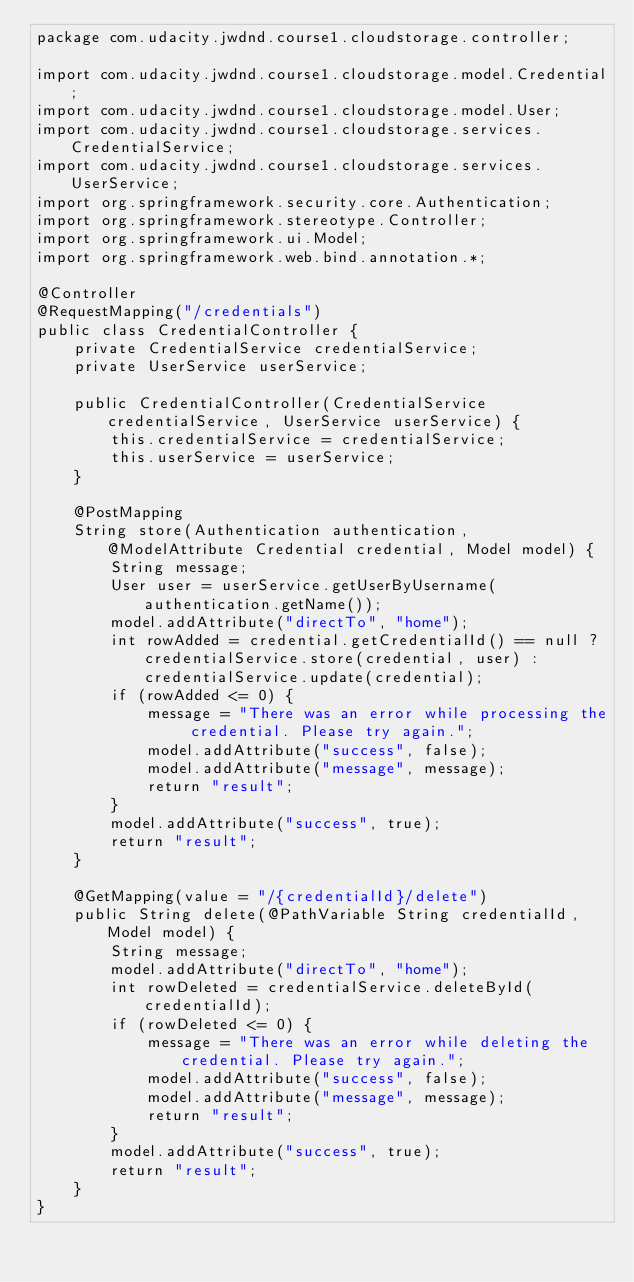<code> <loc_0><loc_0><loc_500><loc_500><_Java_>package com.udacity.jwdnd.course1.cloudstorage.controller;

import com.udacity.jwdnd.course1.cloudstorage.model.Credential;
import com.udacity.jwdnd.course1.cloudstorage.model.User;
import com.udacity.jwdnd.course1.cloudstorage.services.CredentialService;
import com.udacity.jwdnd.course1.cloudstorage.services.UserService;
import org.springframework.security.core.Authentication;
import org.springframework.stereotype.Controller;
import org.springframework.ui.Model;
import org.springframework.web.bind.annotation.*;

@Controller
@RequestMapping("/credentials")
public class CredentialController {
    private CredentialService credentialService;
    private UserService userService;

    public CredentialController(CredentialService credentialService, UserService userService) {
        this.credentialService = credentialService;
        this.userService = userService;
    }

    @PostMapping
    String store(Authentication authentication, @ModelAttribute Credential credential, Model model) {
        String message;
        User user = userService.getUserByUsername(authentication.getName());
        model.addAttribute("directTo", "home");
        int rowAdded = credential.getCredentialId() == null ? credentialService.store(credential, user) : credentialService.update(credential);
        if (rowAdded <= 0) {
            message = "There was an error while processing the credential. Please try again.";
            model.addAttribute("success", false);
            model.addAttribute("message", message);
            return "result";
        }
        model.addAttribute("success", true);
        return "result";
    }

    @GetMapping(value = "/{credentialId}/delete")
    public String delete(@PathVariable String credentialId, Model model) {
        String message;
        model.addAttribute("directTo", "home");
        int rowDeleted = credentialService.deleteById(credentialId);
        if (rowDeleted <= 0) {
            message = "There was an error while deleting the credential. Please try again.";
            model.addAttribute("success", false);
            model.addAttribute("message", message);
            return "result";
        }
        model.addAttribute("success", true);
        return "result";
    }
}
</code> 